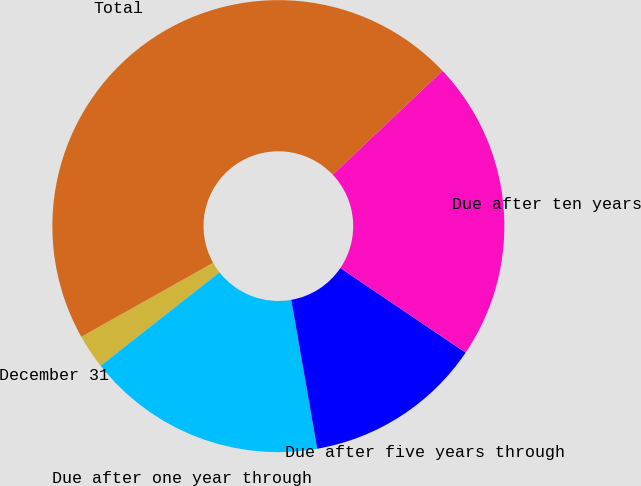Convert chart. <chart><loc_0><loc_0><loc_500><loc_500><pie_chart><fcel>December 31<fcel>Due after one year through<fcel>Due after five years through<fcel>Due after ten years<fcel>Total<nl><fcel>2.46%<fcel>17.15%<fcel>12.79%<fcel>21.52%<fcel>46.07%<nl></chart> 